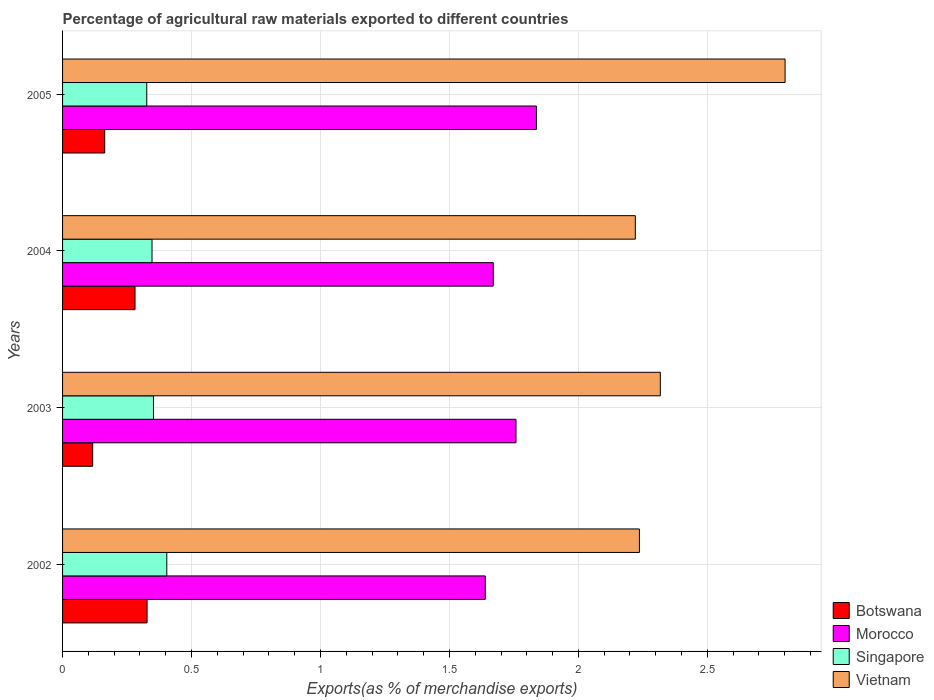How many groups of bars are there?
Give a very brief answer. 4. How many bars are there on the 4th tick from the top?
Offer a very short reply. 4. What is the label of the 2nd group of bars from the top?
Your answer should be very brief. 2004. In how many cases, is the number of bars for a given year not equal to the number of legend labels?
Ensure brevity in your answer.  0. What is the percentage of exports to different countries in Botswana in 2003?
Provide a short and direct response. 0.12. Across all years, what is the maximum percentage of exports to different countries in Singapore?
Provide a short and direct response. 0.4. Across all years, what is the minimum percentage of exports to different countries in Morocco?
Keep it short and to the point. 1.64. In which year was the percentage of exports to different countries in Vietnam minimum?
Give a very brief answer. 2004. What is the total percentage of exports to different countries in Morocco in the graph?
Keep it short and to the point. 6.9. What is the difference between the percentage of exports to different countries in Vietnam in 2002 and that in 2004?
Give a very brief answer. 0.02. What is the difference between the percentage of exports to different countries in Morocco in 2005 and the percentage of exports to different countries in Vietnam in 2003?
Ensure brevity in your answer.  -0.48. What is the average percentage of exports to different countries in Singapore per year?
Give a very brief answer. 0.36. In the year 2003, what is the difference between the percentage of exports to different countries in Singapore and percentage of exports to different countries in Morocco?
Provide a succinct answer. -1.41. What is the ratio of the percentage of exports to different countries in Vietnam in 2002 to that in 2005?
Offer a very short reply. 0.8. Is the percentage of exports to different countries in Botswana in 2002 less than that in 2005?
Ensure brevity in your answer.  No. Is the difference between the percentage of exports to different countries in Singapore in 2004 and 2005 greater than the difference between the percentage of exports to different countries in Morocco in 2004 and 2005?
Offer a very short reply. Yes. What is the difference between the highest and the second highest percentage of exports to different countries in Singapore?
Ensure brevity in your answer.  0.05. What is the difference between the highest and the lowest percentage of exports to different countries in Singapore?
Ensure brevity in your answer.  0.08. Is the sum of the percentage of exports to different countries in Botswana in 2003 and 2005 greater than the maximum percentage of exports to different countries in Morocco across all years?
Keep it short and to the point. No. Is it the case that in every year, the sum of the percentage of exports to different countries in Vietnam and percentage of exports to different countries in Botswana is greater than the sum of percentage of exports to different countries in Morocco and percentage of exports to different countries in Singapore?
Ensure brevity in your answer.  No. What does the 4th bar from the top in 2004 represents?
Offer a very short reply. Botswana. What does the 2nd bar from the bottom in 2003 represents?
Provide a short and direct response. Morocco. Is it the case that in every year, the sum of the percentage of exports to different countries in Vietnam and percentage of exports to different countries in Botswana is greater than the percentage of exports to different countries in Morocco?
Provide a short and direct response. Yes. Are all the bars in the graph horizontal?
Provide a short and direct response. Yes. Are the values on the major ticks of X-axis written in scientific E-notation?
Make the answer very short. No. Does the graph contain any zero values?
Your answer should be compact. No. Where does the legend appear in the graph?
Your answer should be compact. Bottom right. How are the legend labels stacked?
Provide a short and direct response. Vertical. What is the title of the graph?
Provide a short and direct response. Percentage of agricultural raw materials exported to different countries. Does "Vanuatu" appear as one of the legend labels in the graph?
Give a very brief answer. No. What is the label or title of the X-axis?
Offer a terse response. Exports(as % of merchandise exports). What is the Exports(as % of merchandise exports) of Botswana in 2002?
Your answer should be compact. 0.33. What is the Exports(as % of merchandise exports) in Morocco in 2002?
Provide a short and direct response. 1.64. What is the Exports(as % of merchandise exports) of Singapore in 2002?
Provide a succinct answer. 0.4. What is the Exports(as % of merchandise exports) of Vietnam in 2002?
Your answer should be very brief. 2.24. What is the Exports(as % of merchandise exports) of Botswana in 2003?
Provide a short and direct response. 0.12. What is the Exports(as % of merchandise exports) in Morocco in 2003?
Ensure brevity in your answer.  1.76. What is the Exports(as % of merchandise exports) of Singapore in 2003?
Your answer should be compact. 0.35. What is the Exports(as % of merchandise exports) in Vietnam in 2003?
Your answer should be very brief. 2.32. What is the Exports(as % of merchandise exports) of Botswana in 2004?
Offer a terse response. 0.28. What is the Exports(as % of merchandise exports) of Morocco in 2004?
Give a very brief answer. 1.67. What is the Exports(as % of merchandise exports) of Singapore in 2004?
Your answer should be compact. 0.35. What is the Exports(as % of merchandise exports) of Vietnam in 2004?
Your answer should be compact. 2.22. What is the Exports(as % of merchandise exports) in Botswana in 2005?
Keep it short and to the point. 0.16. What is the Exports(as % of merchandise exports) in Morocco in 2005?
Your response must be concise. 1.84. What is the Exports(as % of merchandise exports) in Singapore in 2005?
Offer a very short reply. 0.33. What is the Exports(as % of merchandise exports) of Vietnam in 2005?
Keep it short and to the point. 2.8. Across all years, what is the maximum Exports(as % of merchandise exports) of Botswana?
Keep it short and to the point. 0.33. Across all years, what is the maximum Exports(as % of merchandise exports) of Morocco?
Provide a succinct answer. 1.84. Across all years, what is the maximum Exports(as % of merchandise exports) of Singapore?
Keep it short and to the point. 0.4. Across all years, what is the maximum Exports(as % of merchandise exports) of Vietnam?
Offer a very short reply. 2.8. Across all years, what is the minimum Exports(as % of merchandise exports) in Botswana?
Provide a short and direct response. 0.12. Across all years, what is the minimum Exports(as % of merchandise exports) in Morocco?
Your response must be concise. 1.64. Across all years, what is the minimum Exports(as % of merchandise exports) of Singapore?
Provide a short and direct response. 0.33. Across all years, what is the minimum Exports(as % of merchandise exports) in Vietnam?
Give a very brief answer. 2.22. What is the total Exports(as % of merchandise exports) of Botswana in the graph?
Your answer should be very brief. 0.89. What is the total Exports(as % of merchandise exports) in Morocco in the graph?
Make the answer very short. 6.9. What is the total Exports(as % of merchandise exports) of Singapore in the graph?
Keep it short and to the point. 1.43. What is the total Exports(as % of merchandise exports) of Vietnam in the graph?
Keep it short and to the point. 9.58. What is the difference between the Exports(as % of merchandise exports) in Botswana in 2002 and that in 2003?
Provide a succinct answer. 0.21. What is the difference between the Exports(as % of merchandise exports) in Morocco in 2002 and that in 2003?
Offer a very short reply. -0.12. What is the difference between the Exports(as % of merchandise exports) in Singapore in 2002 and that in 2003?
Provide a short and direct response. 0.05. What is the difference between the Exports(as % of merchandise exports) in Vietnam in 2002 and that in 2003?
Provide a short and direct response. -0.08. What is the difference between the Exports(as % of merchandise exports) in Botswana in 2002 and that in 2004?
Ensure brevity in your answer.  0.05. What is the difference between the Exports(as % of merchandise exports) of Morocco in 2002 and that in 2004?
Keep it short and to the point. -0.03. What is the difference between the Exports(as % of merchandise exports) in Singapore in 2002 and that in 2004?
Ensure brevity in your answer.  0.06. What is the difference between the Exports(as % of merchandise exports) of Vietnam in 2002 and that in 2004?
Offer a terse response. 0.02. What is the difference between the Exports(as % of merchandise exports) of Botswana in 2002 and that in 2005?
Provide a succinct answer. 0.16. What is the difference between the Exports(as % of merchandise exports) in Morocco in 2002 and that in 2005?
Provide a succinct answer. -0.2. What is the difference between the Exports(as % of merchandise exports) in Singapore in 2002 and that in 2005?
Your answer should be very brief. 0.08. What is the difference between the Exports(as % of merchandise exports) in Vietnam in 2002 and that in 2005?
Provide a succinct answer. -0.56. What is the difference between the Exports(as % of merchandise exports) in Botswana in 2003 and that in 2004?
Offer a terse response. -0.16. What is the difference between the Exports(as % of merchandise exports) of Morocco in 2003 and that in 2004?
Offer a very short reply. 0.09. What is the difference between the Exports(as % of merchandise exports) of Singapore in 2003 and that in 2004?
Provide a succinct answer. 0.01. What is the difference between the Exports(as % of merchandise exports) in Vietnam in 2003 and that in 2004?
Provide a short and direct response. 0.1. What is the difference between the Exports(as % of merchandise exports) of Botswana in 2003 and that in 2005?
Your answer should be very brief. -0.05. What is the difference between the Exports(as % of merchandise exports) of Morocco in 2003 and that in 2005?
Make the answer very short. -0.08. What is the difference between the Exports(as % of merchandise exports) in Singapore in 2003 and that in 2005?
Provide a short and direct response. 0.03. What is the difference between the Exports(as % of merchandise exports) of Vietnam in 2003 and that in 2005?
Your response must be concise. -0.48. What is the difference between the Exports(as % of merchandise exports) in Botswana in 2004 and that in 2005?
Your response must be concise. 0.12. What is the difference between the Exports(as % of merchandise exports) of Morocco in 2004 and that in 2005?
Provide a short and direct response. -0.17. What is the difference between the Exports(as % of merchandise exports) of Singapore in 2004 and that in 2005?
Keep it short and to the point. 0.02. What is the difference between the Exports(as % of merchandise exports) in Vietnam in 2004 and that in 2005?
Offer a very short reply. -0.58. What is the difference between the Exports(as % of merchandise exports) in Botswana in 2002 and the Exports(as % of merchandise exports) in Morocco in 2003?
Offer a terse response. -1.43. What is the difference between the Exports(as % of merchandise exports) of Botswana in 2002 and the Exports(as % of merchandise exports) of Singapore in 2003?
Offer a very short reply. -0.02. What is the difference between the Exports(as % of merchandise exports) in Botswana in 2002 and the Exports(as % of merchandise exports) in Vietnam in 2003?
Provide a succinct answer. -1.99. What is the difference between the Exports(as % of merchandise exports) in Morocco in 2002 and the Exports(as % of merchandise exports) in Singapore in 2003?
Your answer should be compact. 1.29. What is the difference between the Exports(as % of merchandise exports) in Morocco in 2002 and the Exports(as % of merchandise exports) in Vietnam in 2003?
Provide a short and direct response. -0.68. What is the difference between the Exports(as % of merchandise exports) of Singapore in 2002 and the Exports(as % of merchandise exports) of Vietnam in 2003?
Ensure brevity in your answer.  -1.91. What is the difference between the Exports(as % of merchandise exports) of Botswana in 2002 and the Exports(as % of merchandise exports) of Morocco in 2004?
Offer a terse response. -1.34. What is the difference between the Exports(as % of merchandise exports) of Botswana in 2002 and the Exports(as % of merchandise exports) of Singapore in 2004?
Offer a very short reply. -0.02. What is the difference between the Exports(as % of merchandise exports) in Botswana in 2002 and the Exports(as % of merchandise exports) in Vietnam in 2004?
Your answer should be very brief. -1.89. What is the difference between the Exports(as % of merchandise exports) in Morocco in 2002 and the Exports(as % of merchandise exports) in Singapore in 2004?
Make the answer very short. 1.29. What is the difference between the Exports(as % of merchandise exports) of Morocco in 2002 and the Exports(as % of merchandise exports) of Vietnam in 2004?
Offer a very short reply. -0.58. What is the difference between the Exports(as % of merchandise exports) of Singapore in 2002 and the Exports(as % of merchandise exports) of Vietnam in 2004?
Make the answer very short. -1.82. What is the difference between the Exports(as % of merchandise exports) of Botswana in 2002 and the Exports(as % of merchandise exports) of Morocco in 2005?
Your answer should be very brief. -1.51. What is the difference between the Exports(as % of merchandise exports) of Botswana in 2002 and the Exports(as % of merchandise exports) of Singapore in 2005?
Your answer should be compact. 0. What is the difference between the Exports(as % of merchandise exports) of Botswana in 2002 and the Exports(as % of merchandise exports) of Vietnam in 2005?
Provide a succinct answer. -2.47. What is the difference between the Exports(as % of merchandise exports) in Morocco in 2002 and the Exports(as % of merchandise exports) in Singapore in 2005?
Provide a short and direct response. 1.31. What is the difference between the Exports(as % of merchandise exports) of Morocco in 2002 and the Exports(as % of merchandise exports) of Vietnam in 2005?
Offer a terse response. -1.16. What is the difference between the Exports(as % of merchandise exports) of Singapore in 2002 and the Exports(as % of merchandise exports) of Vietnam in 2005?
Provide a succinct answer. -2.4. What is the difference between the Exports(as % of merchandise exports) in Botswana in 2003 and the Exports(as % of merchandise exports) in Morocco in 2004?
Provide a short and direct response. -1.55. What is the difference between the Exports(as % of merchandise exports) of Botswana in 2003 and the Exports(as % of merchandise exports) of Singapore in 2004?
Your response must be concise. -0.23. What is the difference between the Exports(as % of merchandise exports) in Botswana in 2003 and the Exports(as % of merchandise exports) in Vietnam in 2004?
Your answer should be compact. -2.1. What is the difference between the Exports(as % of merchandise exports) of Morocco in 2003 and the Exports(as % of merchandise exports) of Singapore in 2004?
Your answer should be compact. 1.41. What is the difference between the Exports(as % of merchandise exports) in Morocco in 2003 and the Exports(as % of merchandise exports) in Vietnam in 2004?
Provide a short and direct response. -0.46. What is the difference between the Exports(as % of merchandise exports) in Singapore in 2003 and the Exports(as % of merchandise exports) in Vietnam in 2004?
Offer a very short reply. -1.87. What is the difference between the Exports(as % of merchandise exports) of Botswana in 2003 and the Exports(as % of merchandise exports) of Morocco in 2005?
Give a very brief answer. -1.72. What is the difference between the Exports(as % of merchandise exports) of Botswana in 2003 and the Exports(as % of merchandise exports) of Singapore in 2005?
Your response must be concise. -0.21. What is the difference between the Exports(as % of merchandise exports) in Botswana in 2003 and the Exports(as % of merchandise exports) in Vietnam in 2005?
Your answer should be compact. -2.68. What is the difference between the Exports(as % of merchandise exports) of Morocco in 2003 and the Exports(as % of merchandise exports) of Singapore in 2005?
Make the answer very short. 1.43. What is the difference between the Exports(as % of merchandise exports) in Morocco in 2003 and the Exports(as % of merchandise exports) in Vietnam in 2005?
Provide a short and direct response. -1.04. What is the difference between the Exports(as % of merchandise exports) of Singapore in 2003 and the Exports(as % of merchandise exports) of Vietnam in 2005?
Give a very brief answer. -2.45. What is the difference between the Exports(as % of merchandise exports) of Botswana in 2004 and the Exports(as % of merchandise exports) of Morocco in 2005?
Give a very brief answer. -1.56. What is the difference between the Exports(as % of merchandise exports) of Botswana in 2004 and the Exports(as % of merchandise exports) of Singapore in 2005?
Make the answer very short. -0.05. What is the difference between the Exports(as % of merchandise exports) of Botswana in 2004 and the Exports(as % of merchandise exports) of Vietnam in 2005?
Give a very brief answer. -2.52. What is the difference between the Exports(as % of merchandise exports) of Morocco in 2004 and the Exports(as % of merchandise exports) of Singapore in 2005?
Offer a terse response. 1.34. What is the difference between the Exports(as % of merchandise exports) in Morocco in 2004 and the Exports(as % of merchandise exports) in Vietnam in 2005?
Ensure brevity in your answer.  -1.13. What is the difference between the Exports(as % of merchandise exports) in Singapore in 2004 and the Exports(as % of merchandise exports) in Vietnam in 2005?
Make the answer very short. -2.45. What is the average Exports(as % of merchandise exports) of Botswana per year?
Keep it short and to the point. 0.22. What is the average Exports(as % of merchandise exports) of Morocco per year?
Ensure brevity in your answer.  1.73. What is the average Exports(as % of merchandise exports) in Singapore per year?
Offer a very short reply. 0.36. What is the average Exports(as % of merchandise exports) in Vietnam per year?
Your answer should be very brief. 2.39. In the year 2002, what is the difference between the Exports(as % of merchandise exports) of Botswana and Exports(as % of merchandise exports) of Morocco?
Your answer should be compact. -1.31. In the year 2002, what is the difference between the Exports(as % of merchandise exports) of Botswana and Exports(as % of merchandise exports) of Singapore?
Make the answer very short. -0.08. In the year 2002, what is the difference between the Exports(as % of merchandise exports) in Botswana and Exports(as % of merchandise exports) in Vietnam?
Offer a terse response. -1.91. In the year 2002, what is the difference between the Exports(as % of merchandise exports) of Morocco and Exports(as % of merchandise exports) of Singapore?
Your answer should be very brief. 1.23. In the year 2002, what is the difference between the Exports(as % of merchandise exports) in Morocco and Exports(as % of merchandise exports) in Vietnam?
Ensure brevity in your answer.  -0.6. In the year 2002, what is the difference between the Exports(as % of merchandise exports) of Singapore and Exports(as % of merchandise exports) of Vietnam?
Give a very brief answer. -1.83. In the year 2003, what is the difference between the Exports(as % of merchandise exports) of Botswana and Exports(as % of merchandise exports) of Morocco?
Make the answer very short. -1.64. In the year 2003, what is the difference between the Exports(as % of merchandise exports) in Botswana and Exports(as % of merchandise exports) in Singapore?
Your answer should be compact. -0.24. In the year 2003, what is the difference between the Exports(as % of merchandise exports) in Botswana and Exports(as % of merchandise exports) in Vietnam?
Your response must be concise. -2.2. In the year 2003, what is the difference between the Exports(as % of merchandise exports) in Morocco and Exports(as % of merchandise exports) in Singapore?
Your answer should be compact. 1.41. In the year 2003, what is the difference between the Exports(as % of merchandise exports) of Morocco and Exports(as % of merchandise exports) of Vietnam?
Keep it short and to the point. -0.56. In the year 2003, what is the difference between the Exports(as % of merchandise exports) of Singapore and Exports(as % of merchandise exports) of Vietnam?
Give a very brief answer. -1.97. In the year 2004, what is the difference between the Exports(as % of merchandise exports) of Botswana and Exports(as % of merchandise exports) of Morocco?
Provide a short and direct response. -1.39. In the year 2004, what is the difference between the Exports(as % of merchandise exports) of Botswana and Exports(as % of merchandise exports) of Singapore?
Provide a succinct answer. -0.07. In the year 2004, what is the difference between the Exports(as % of merchandise exports) in Botswana and Exports(as % of merchandise exports) in Vietnam?
Provide a succinct answer. -1.94. In the year 2004, what is the difference between the Exports(as % of merchandise exports) of Morocco and Exports(as % of merchandise exports) of Singapore?
Offer a very short reply. 1.32. In the year 2004, what is the difference between the Exports(as % of merchandise exports) in Morocco and Exports(as % of merchandise exports) in Vietnam?
Your answer should be compact. -0.55. In the year 2004, what is the difference between the Exports(as % of merchandise exports) of Singapore and Exports(as % of merchandise exports) of Vietnam?
Provide a succinct answer. -1.87. In the year 2005, what is the difference between the Exports(as % of merchandise exports) in Botswana and Exports(as % of merchandise exports) in Morocco?
Offer a terse response. -1.67. In the year 2005, what is the difference between the Exports(as % of merchandise exports) of Botswana and Exports(as % of merchandise exports) of Singapore?
Provide a short and direct response. -0.16. In the year 2005, what is the difference between the Exports(as % of merchandise exports) of Botswana and Exports(as % of merchandise exports) of Vietnam?
Offer a very short reply. -2.64. In the year 2005, what is the difference between the Exports(as % of merchandise exports) of Morocco and Exports(as % of merchandise exports) of Singapore?
Offer a very short reply. 1.51. In the year 2005, what is the difference between the Exports(as % of merchandise exports) in Morocco and Exports(as % of merchandise exports) in Vietnam?
Provide a short and direct response. -0.96. In the year 2005, what is the difference between the Exports(as % of merchandise exports) in Singapore and Exports(as % of merchandise exports) in Vietnam?
Offer a terse response. -2.48. What is the ratio of the Exports(as % of merchandise exports) in Botswana in 2002 to that in 2003?
Make the answer very short. 2.81. What is the ratio of the Exports(as % of merchandise exports) of Morocco in 2002 to that in 2003?
Provide a succinct answer. 0.93. What is the ratio of the Exports(as % of merchandise exports) in Singapore in 2002 to that in 2003?
Your response must be concise. 1.15. What is the ratio of the Exports(as % of merchandise exports) in Botswana in 2002 to that in 2004?
Make the answer very short. 1.17. What is the ratio of the Exports(as % of merchandise exports) of Morocco in 2002 to that in 2004?
Provide a succinct answer. 0.98. What is the ratio of the Exports(as % of merchandise exports) of Singapore in 2002 to that in 2004?
Make the answer very short. 1.17. What is the ratio of the Exports(as % of merchandise exports) of Vietnam in 2002 to that in 2004?
Provide a short and direct response. 1.01. What is the ratio of the Exports(as % of merchandise exports) of Botswana in 2002 to that in 2005?
Give a very brief answer. 2. What is the ratio of the Exports(as % of merchandise exports) of Morocco in 2002 to that in 2005?
Your answer should be very brief. 0.89. What is the ratio of the Exports(as % of merchandise exports) of Singapore in 2002 to that in 2005?
Your response must be concise. 1.24. What is the ratio of the Exports(as % of merchandise exports) in Vietnam in 2002 to that in 2005?
Offer a terse response. 0.8. What is the ratio of the Exports(as % of merchandise exports) of Botswana in 2003 to that in 2004?
Give a very brief answer. 0.42. What is the ratio of the Exports(as % of merchandise exports) of Morocco in 2003 to that in 2004?
Your answer should be compact. 1.05. What is the ratio of the Exports(as % of merchandise exports) in Singapore in 2003 to that in 2004?
Offer a terse response. 1.02. What is the ratio of the Exports(as % of merchandise exports) in Vietnam in 2003 to that in 2004?
Keep it short and to the point. 1.04. What is the ratio of the Exports(as % of merchandise exports) of Botswana in 2003 to that in 2005?
Keep it short and to the point. 0.71. What is the ratio of the Exports(as % of merchandise exports) in Morocco in 2003 to that in 2005?
Provide a short and direct response. 0.96. What is the ratio of the Exports(as % of merchandise exports) in Singapore in 2003 to that in 2005?
Your answer should be very brief. 1.08. What is the ratio of the Exports(as % of merchandise exports) in Vietnam in 2003 to that in 2005?
Ensure brevity in your answer.  0.83. What is the ratio of the Exports(as % of merchandise exports) in Botswana in 2004 to that in 2005?
Give a very brief answer. 1.72. What is the ratio of the Exports(as % of merchandise exports) of Morocco in 2004 to that in 2005?
Give a very brief answer. 0.91. What is the ratio of the Exports(as % of merchandise exports) of Singapore in 2004 to that in 2005?
Your answer should be very brief. 1.06. What is the ratio of the Exports(as % of merchandise exports) of Vietnam in 2004 to that in 2005?
Make the answer very short. 0.79. What is the difference between the highest and the second highest Exports(as % of merchandise exports) of Botswana?
Provide a succinct answer. 0.05. What is the difference between the highest and the second highest Exports(as % of merchandise exports) of Morocco?
Your answer should be very brief. 0.08. What is the difference between the highest and the second highest Exports(as % of merchandise exports) of Singapore?
Offer a very short reply. 0.05. What is the difference between the highest and the second highest Exports(as % of merchandise exports) in Vietnam?
Your answer should be compact. 0.48. What is the difference between the highest and the lowest Exports(as % of merchandise exports) in Botswana?
Provide a succinct answer. 0.21. What is the difference between the highest and the lowest Exports(as % of merchandise exports) in Morocco?
Provide a succinct answer. 0.2. What is the difference between the highest and the lowest Exports(as % of merchandise exports) in Singapore?
Make the answer very short. 0.08. What is the difference between the highest and the lowest Exports(as % of merchandise exports) of Vietnam?
Offer a very short reply. 0.58. 